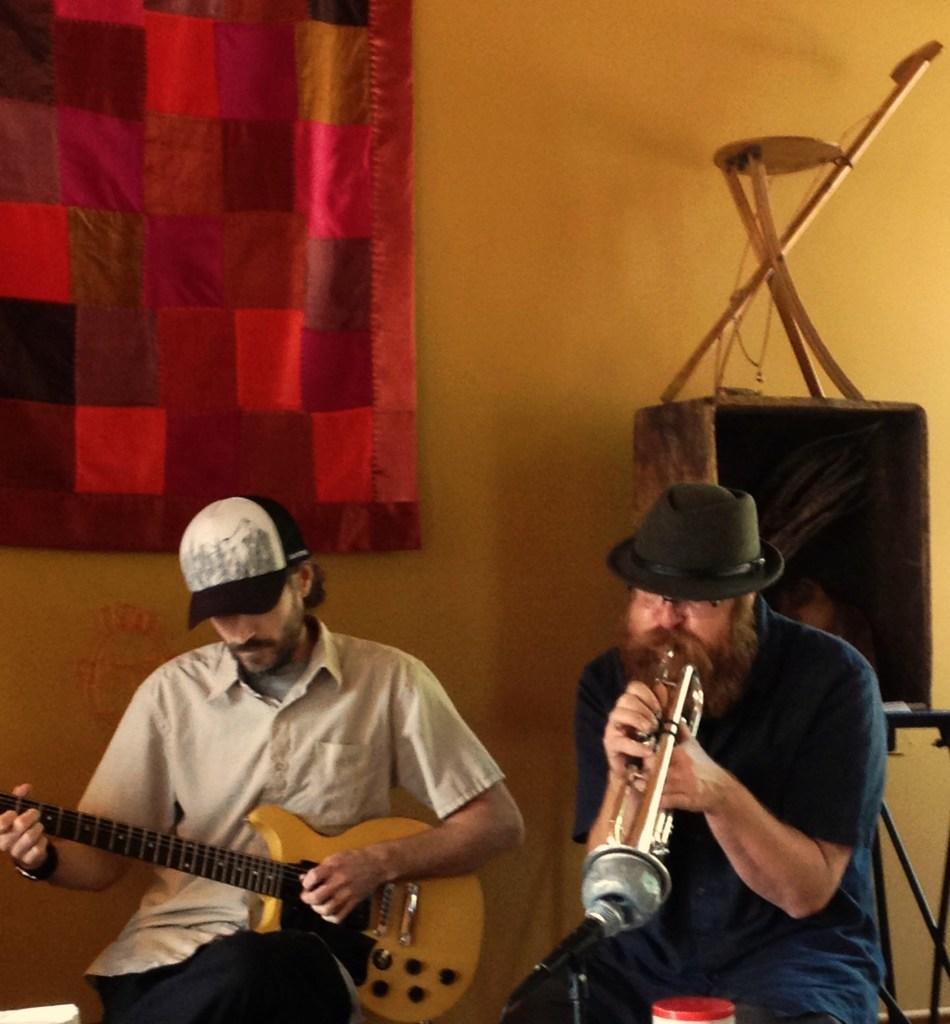Could you give a brief overview of what you see in this image? This picture shows a man seated and playing a trumpet and we see the man seated and playing guitar and we see e a curtain to the window and a foldable chair on the table 